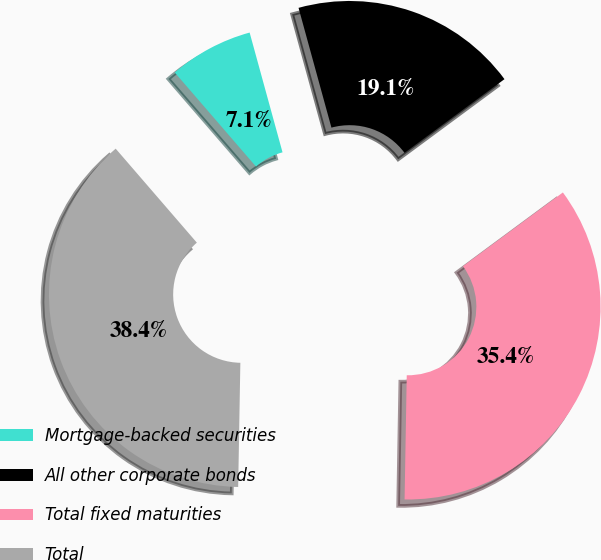Convert chart. <chart><loc_0><loc_0><loc_500><loc_500><pie_chart><fcel>Mortgage-backed securities<fcel>All other corporate bonds<fcel>Total fixed maturities<fcel>Total<nl><fcel>7.07%<fcel>19.14%<fcel>35.4%<fcel>38.38%<nl></chart> 